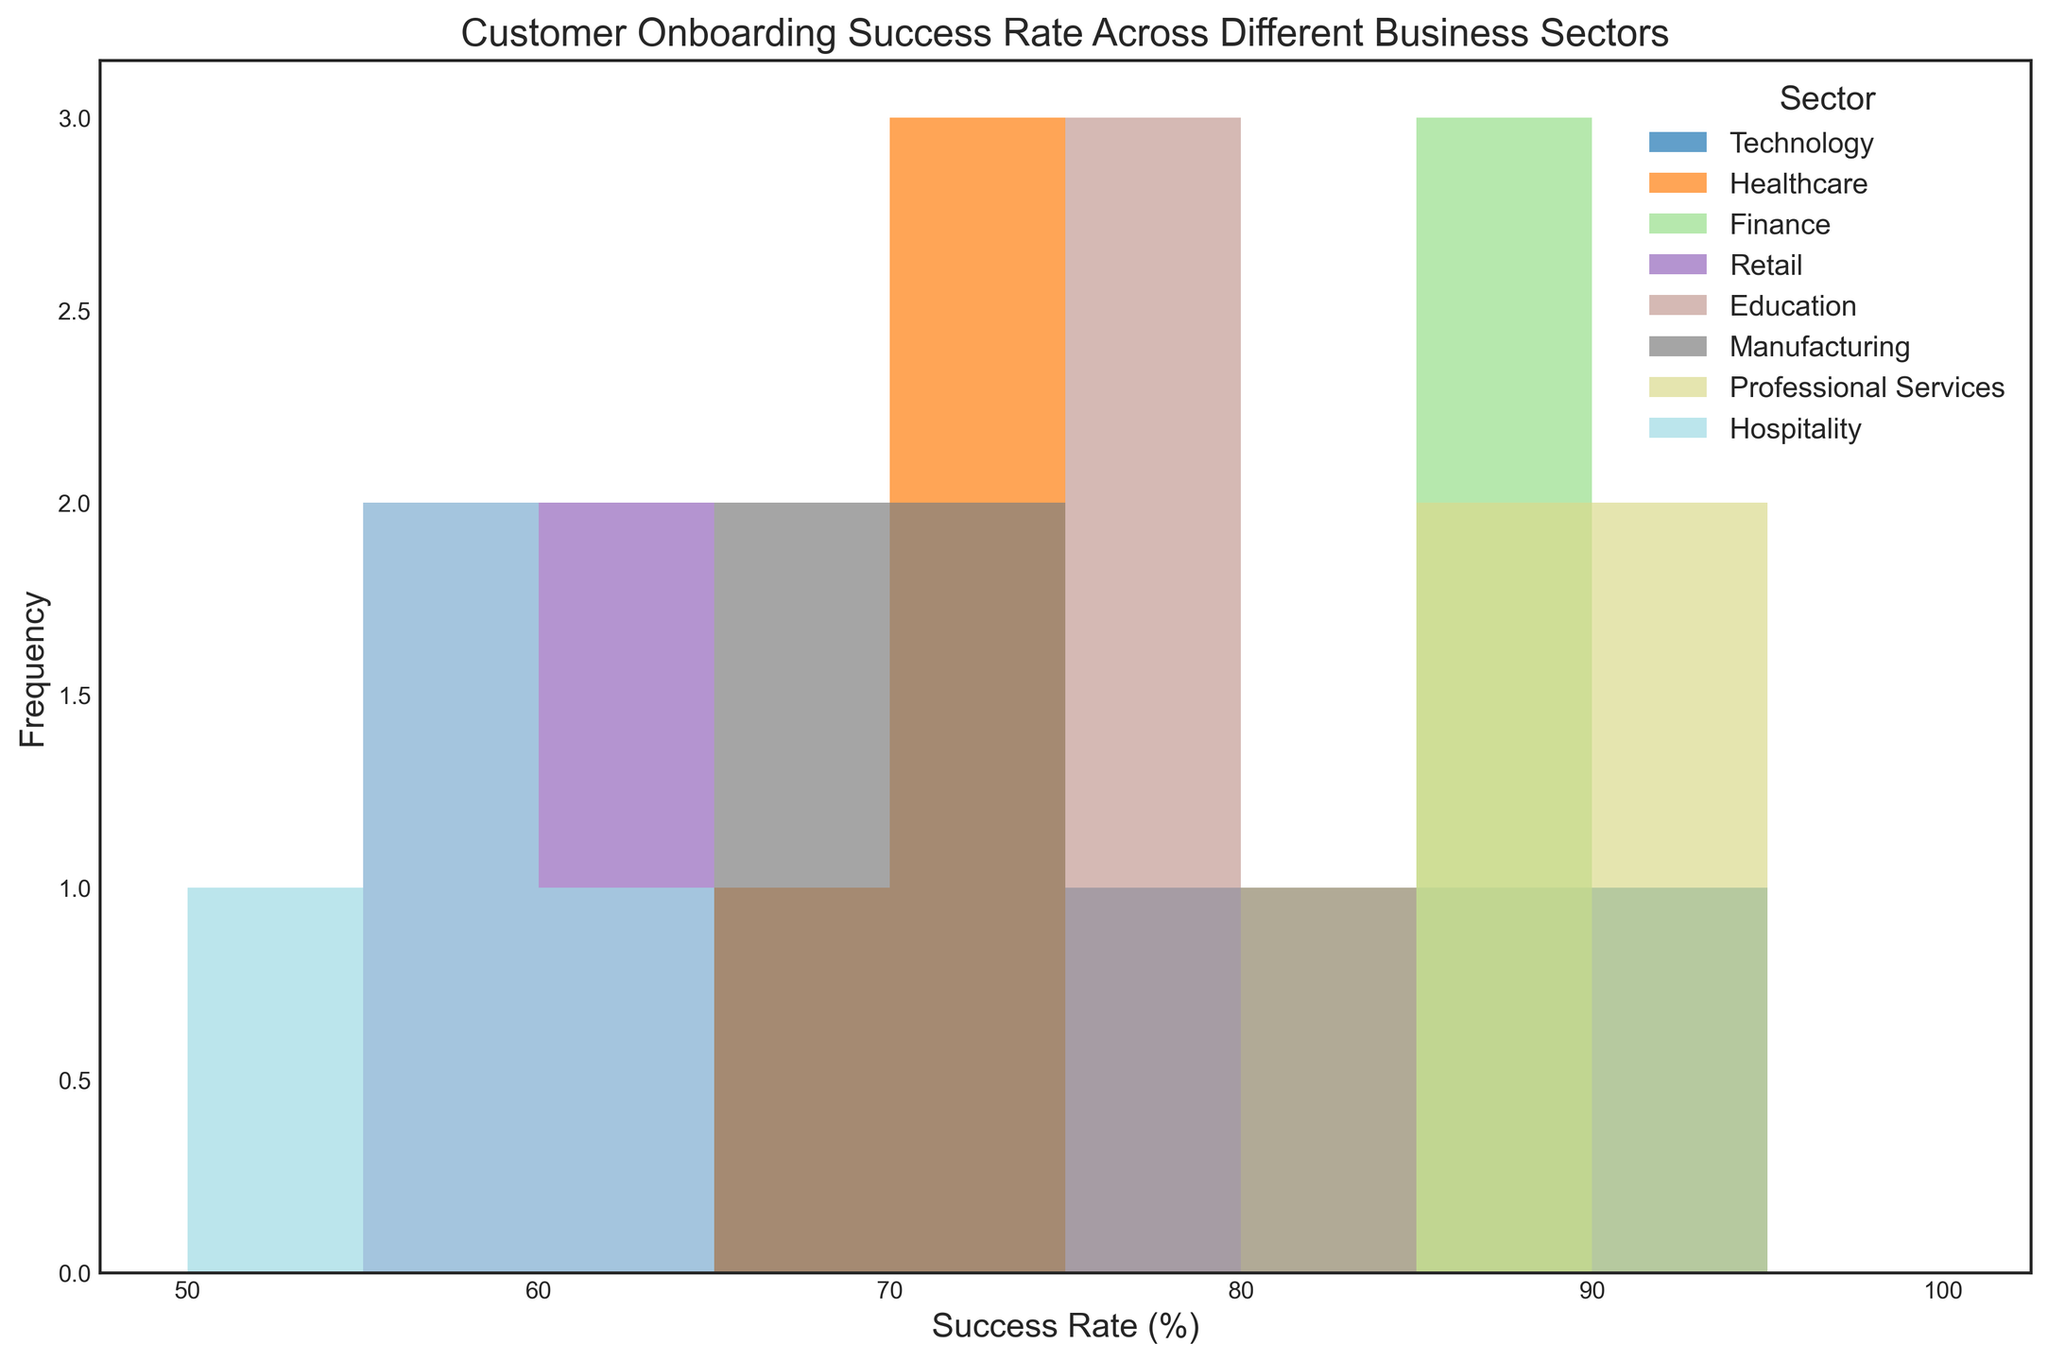What sector has the highest frequency of success rates in the 85-90% range? By examining the histogram, look for the tallest bars within the 85-90% success rate range. Note which sector is indicated by the color label matched with these bars. The sector with the highest frequency will have the tallest bar(s) in this range.
Answer: Technology Which sector has the lowest onboarding success rates and what are those rates? Identify the sector associated with the lowest range of success rates by finding the shortest bars and reading the sector label corresponding to those bars. Check to see the actual success rates for these lowest values.
Answer: Retail, 55%-62% Compare the number of occurrences of success rates in the range 65-70% between Manufacturing and Healthcare sectors. Which sector has more occurrences? Look at the histogram bars for both Manufacturing and Healthcare in the range of 65-70%. Count the number of bars for each sector. The sector with more bars in this range has more occurrences.
Answer: Manufacturing In which range do the success rates of Finance sector predominantly lie? Observe the bars representing the Finance sector. Identify the range where most bars (i.e., the tallest bars) fall within. This range represents the dominant success rates for Finance.
Answer: 82-88% What is the common success rate range for Professional Services? Locate the bars for Professional Services and find the range where they mainly cluster together. This range is their common success rate.
Answer: 87-92% Which sector shows a wider spread in success rates based on the histogram? By examining the sectors, identify the one with bars that cover a broader range of success rates, from its lowest to highest values. A wider spread indicates more variability.
Answer: Technology How many sectors have their success rates clustered mostly around the 55-60% range? Look for sectors with a concentration of bars mainly between 55-60%. Count these sectors by identifying the bars and their corresponding sector colors.
Answer: 2 (Retail, Hospitality) What is the difference in the highest success rate observed between the Healthcare and Technology sectors? Identify the highest success rate bars for both Healthcare and Technology sectors. Subtract the highest rate of Healthcare from the highest rate of Technology to get the difference.
Answer: 15 (Technology highest: 90%, Healthcare highest: 75%) Compare the visual distribution of success rates in Education and Manufacturing sectors. Which one has bars clustered closer together? Observe the bars for Education and Manufacturing. The sector whose bars are more concentrated in a narrower range has closer clustered values.
Answer: Education What is the combined frequency of success rates within the range 70-75% across all sectors? Identify the success rates of 70-75% across all sectors and count their individual frequencies. Sum these to get the combined frequency within this range.
Answer: 7 